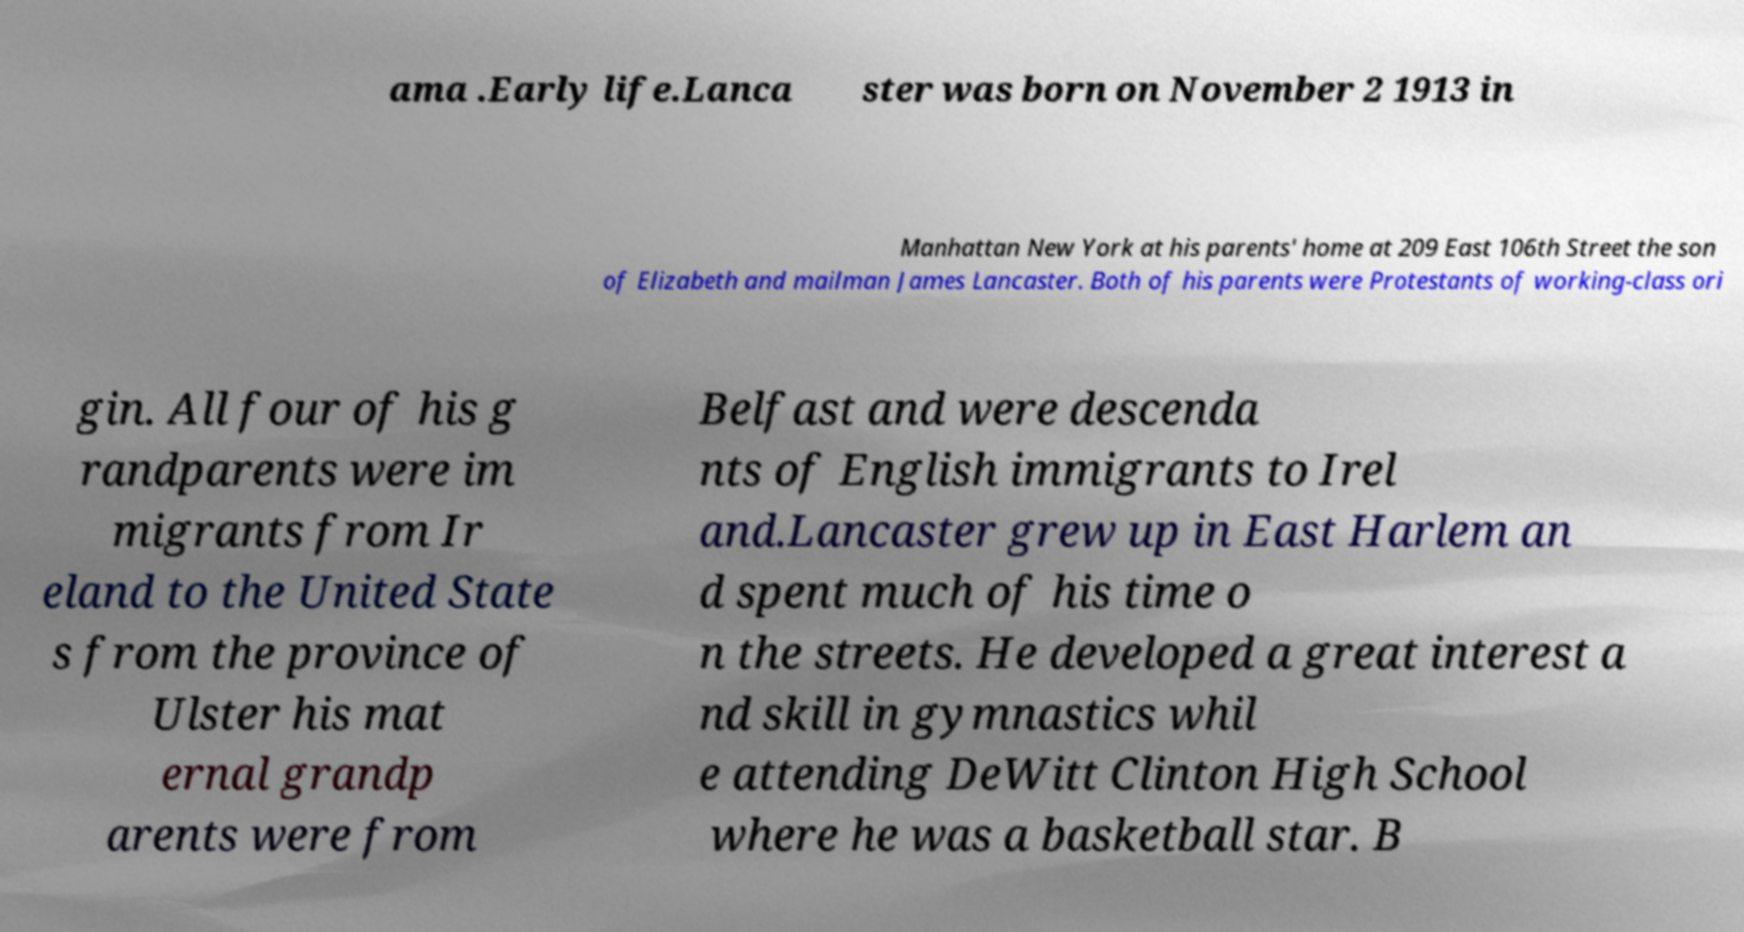Can you read and provide the text displayed in the image?This photo seems to have some interesting text. Can you extract and type it out for me? ama .Early life.Lanca ster was born on November 2 1913 in Manhattan New York at his parents' home at 209 East 106th Street the son of Elizabeth and mailman James Lancaster. Both of his parents were Protestants of working-class ori gin. All four of his g randparents were im migrants from Ir eland to the United State s from the province of Ulster his mat ernal grandp arents were from Belfast and were descenda nts of English immigrants to Irel and.Lancaster grew up in East Harlem an d spent much of his time o n the streets. He developed a great interest a nd skill in gymnastics whil e attending DeWitt Clinton High School where he was a basketball star. B 